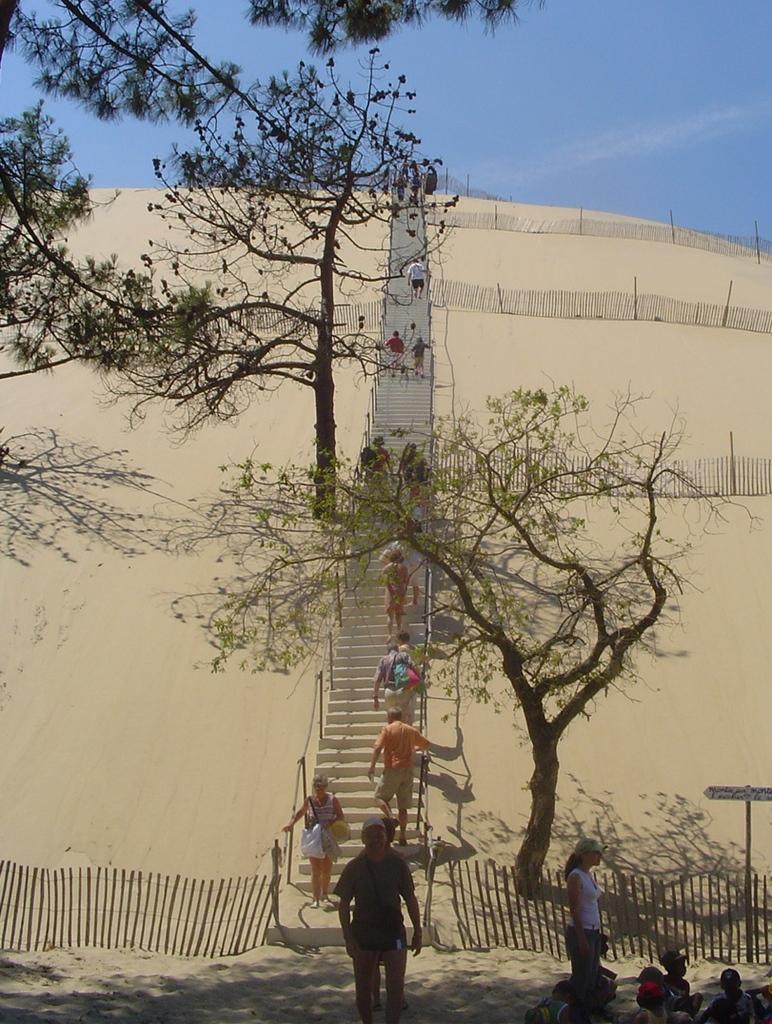What is located in the center of the image? In the center of the image, there is a fence, a staircase, a pole, a sign board, and people. Can you describe the elements in the center of the image? The fence is likely a barrier, the staircase provides access to different levels, the pole could be for support or signage, the sign board displays information, and the people are likely visitors or passersby. What can be seen in the background of the image? In the background of the image, there are clouds, trees, fences, and sand visible. How would you describe the sky in the image? The sky is visible in the background of the image, and it has clouds. Reasoning: Let's think step by step by step in order to produce the conversation. We start by identifying the main subjects and objects in the image based on the provided facts. We then formulate questions that focus on the location and characteristics of these subjects and objects, ensuring that each question can be answered definitively with the information given. We avoid yes/no questions and ensure that the language is simple and clear. Absurd Question/Answer: What type of distribution system is being used by the snails in the image? There are no snails present in the image, so it is not possible to determine the type of distribution system they might be using. 